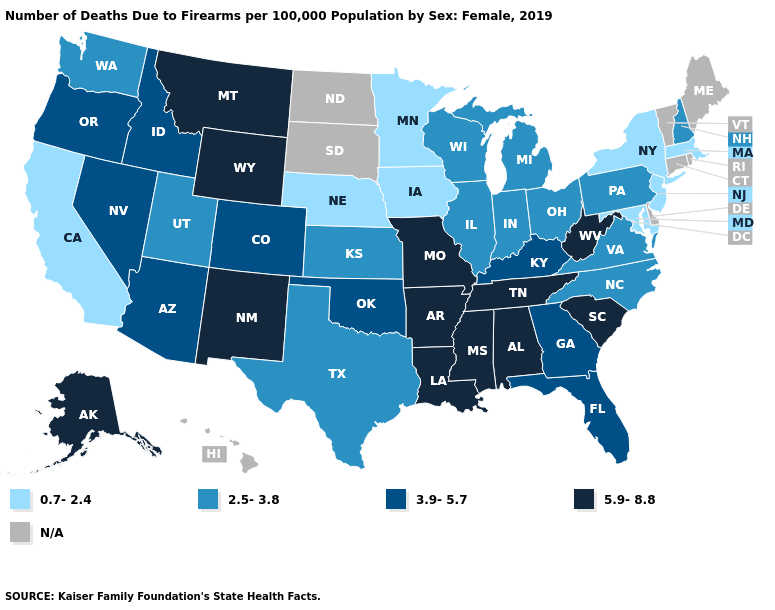What is the highest value in states that border New York?
Concise answer only. 2.5-3.8. Which states have the lowest value in the USA?
Give a very brief answer. California, Iowa, Maryland, Massachusetts, Minnesota, Nebraska, New Jersey, New York. Does the map have missing data?
Keep it brief. Yes. What is the value of Michigan?
Concise answer only. 2.5-3.8. What is the value of Delaware?
Be succinct. N/A. What is the lowest value in the West?
Be succinct. 0.7-2.4. Does the map have missing data?
Short answer required. Yes. What is the value of Delaware?
Keep it brief. N/A. Does Oklahoma have the lowest value in the USA?
Be succinct. No. Does Arkansas have the highest value in the USA?
Concise answer only. Yes. What is the value of Idaho?
Write a very short answer. 3.9-5.7. What is the value of South Dakota?
Short answer required. N/A. 